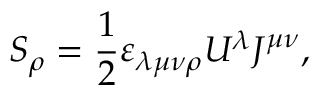Convert formula to latex. <formula><loc_0><loc_0><loc_500><loc_500>S _ { \rho } = { \frac { 1 } { 2 } } \varepsilon _ { \lambda \mu \nu \rho } U ^ { \lambda } J ^ { \mu \nu } ,</formula> 